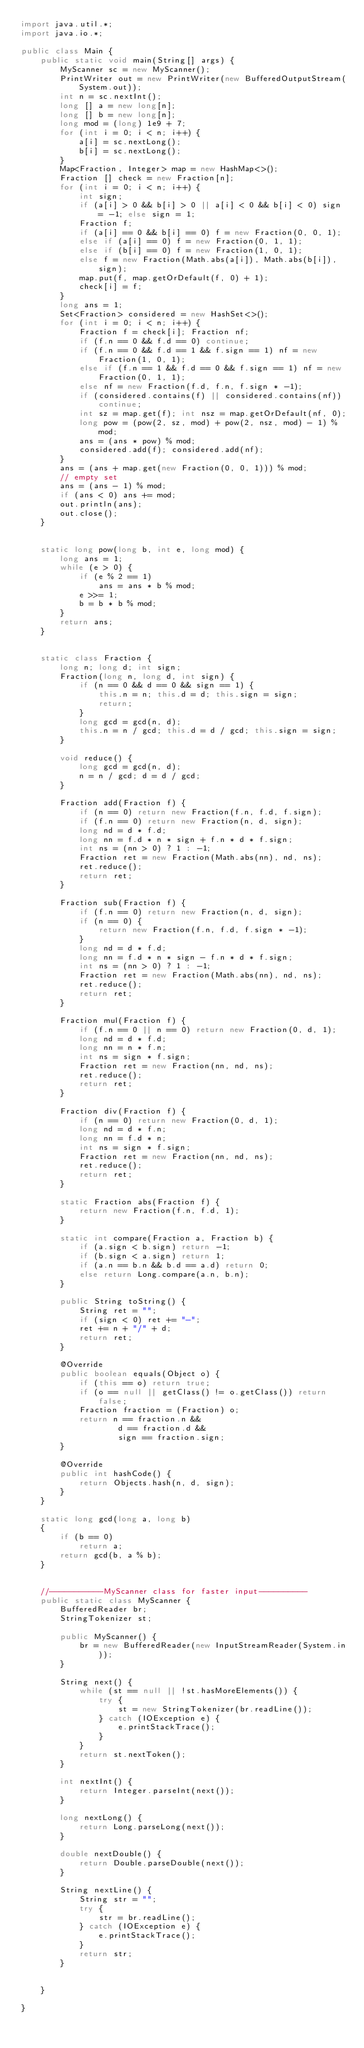<code> <loc_0><loc_0><loc_500><loc_500><_Java_>import java.util.*;
import java.io.*;

public class Main {
    public static void main(String[] args) {
        MyScanner sc = new MyScanner();
        PrintWriter out = new PrintWriter(new BufferedOutputStream(System.out));
        int n = sc.nextInt();
        long [] a = new long[n];
        long [] b = new long[n];
        long mod = (long) 1e9 + 7;
        for (int i = 0; i < n; i++) {
            a[i] = sc.nextLong();
            b[i] = sc.nextLong();
        }
        Map<Fraction, Integer> map = new HashMap<>();
        Fraction [] check = new Fraction[n];
        for (int i = 0; i < n; i++) {
            int sign;
            if (a[i] > 0 && b[i] > 0 || a[i] < 0 && b[i] < 0) sign = -1; else sign = 1;
            Fraction f;
            if (a[i] == 0 && b[i] == 0) f = new Fraction(0, 0, 1);
            else if (a[i] == 0) f = new Fraction(0, 1, 1);
            else if (b[i] == 0) f = new Fraction(1, 0, 1);
            else f = new Fraction(Math.abs(a[i]), Math.abs(b[i]), sign);
            map.put(f, map.getOrDefault(f, 0) + 1);
            check[i] = f;
        }
        long ans = 1;
        Set<Fraction> considered = new HashSet<>();
        for (int i = 0; i < n; i++) {
            Fraction f = check[i]; Fraction nf;
            if (f.n == 0 && f.d == 0) continue;
            if (f.n == 0 && f.d == 1 && f.sign == 1) nf = new Fraction(1, 0, 1);
            else if (f.n == 1 && f.d == 0 && f.sign == 1) nf = new Fraction(0, 1, 1);
            else nf = new Fraction(f.d, f.n, f.sign * -1);
            if (considered.contains(f) || considered.contains(nf)) continue;
            int sz = map.get(f); int nsz = map.getOrDefault(nf, 0);
            long pow = (pow(2, sz, mod) + pow(2, nsz, mod) - 1) % mod;
            ans = (ans * pow) % mod;
            considered.add(f); considered.add(nf);
        }
        ans = (ans + map.get(new Fraction(0, 0, 1))) % mod;
        // empty set
        ans = (ans - 1) % mod;
        if (ans < 0) ans += mod;
        out.println(ans);
        out.close();
    }


    static long pow(long b, int e, long mod) {
        long ans = 1;
        while (e > 0) {
            if (e % 2 == 1)
                ans = ans * b % mod;
            e >>= 1;
            b = b * b % mod;
        }
        return ans;
    }


    static class Fraction {
        long n; long d; int sign;
        Fraction(long n, long d, int sign) {
            if (n == 0 && d == 0 && sign == 1) {
                this.n = n; this.d = d; this.sign = sign;
                return;
            }
            long gcd = gcd(n, d);
            this.n = n / gcd; this.d = d / gcd; this.sign = sign;
        }

        void reduce() {
            long gcd = gcd(n, d);
            n = n / gcd; d = d / gcd;
        }

        Fraction add(Fraction f) {
            if (n == 0) return new Fraction(f.n, f.d, f.sign);
            if (f.n == 0) return new Fraction(n, d, sign);
            long nd = d * f.d;
            long nn = f.d * n * sign + f.n * d * f.sign;
            int ns = (nn > 0) ? 1 : -1;
            Fraction ret = new Fraction(Math.abs(nn), nd, ns);
            ret.reduce();
            return ret;
        }

        Fraction sub(Fraction f) {
            if (f.n == 0) return new Fraction(n, d, sign);
            if (n == 0) {
                return new Fraction(f.n, f.d, f.sign * -1);
            }
            long nd = d * f.d;
            long nn = f.d * n * sign - f.n * d * f.sign;
            int ns = (nn > 0) ? 1 : -1;
            Fraction ret = new Fraction(Math.abs(nn), nd, ns);
            ret.reduce();
            return ret;
        }

        Fraction mul(Fraction f) {
            if (f.n == 0 || n == 0) return new Fraction(0, d, 1);
            long nd = d * f.d;
            long nn = n * f.n;
            int ns = sign * f.sign;
            Fraction ret = new Fraction(nn, nd, ns);
            ret.reduce();
            return ret;
        }

        Fraction div(Fraction f) {
            if (n == 0) return new Fraction(0, d, 1);
            long nd = d * f.n;
            long nn = f.d * n;
            int ns = sign * f.sign;
            Fraction ret = new Fraction(nn, nd, ns);
            ret.reduce();
            return ret;
        }

        static Fraction abs(Fraction f) {
            return new Fraction(f.n, f.d, 1);
        }

        static int compare(Fraction a, Fraction b) {
            if (a.sign < b.sign) return -1;
            if (b.sign < a.sign) return 1;
            if (a.n == b.n && b.d == a.d) return 0;
            else return Long.compare(a.n, b.n);
        }

        public String toString() {
            String ret = "";
            if (sign < 0) ret += "-";
            ret += n + "/" + d;
            return ret;
        }

        @Override
        public boolean equals(Object o) {
            if (this == o) return true;
            if (o == null || getClass() != o.getClass()) return false;
            Fraction fraction = (Fraction) o;
            return n == fraction.n &&
                    d == fraction.d &&
                    sign == fraction.sign;
        }

        @Override
        public int hashCode() {
            return Objects.hash(n, d, sign);
        }
    }

    static long gcd(long a, long b)
    {
        if (b == 0)
            return a;
        return gcd(b, a % b);
    }


    //-----------MyScanner class for faster input----------
    public static class MyScanner {
        BufferedReader br;
        StringTokenizer st;

        public MyScanner() {
            br = new BufferedReader(new InputStreamReader(System.in));
        }

        String next() {
            while (st == null || !st.hasMoreElements()) {
                try {
                    st = new StringTokenizer(br.readLine());
                } catch (IOException e) {
                    e.printStackTrace();
                }
            }
            return st.nextToken();
        }

        int nextInt() {
            return Integer.parseInt(next());
        }

        long nextLong() {
            return Long.parseLong(next());
        }

        double nextDouble() {
            return Double.parseDouble(next());
        }

        String nextLine() {
            String str = "";
            try {
                str = br.readLine();
            } catch (IOException e) {
                e.printStackTrace();
            }
            return str;
        }


    }

}</code> 